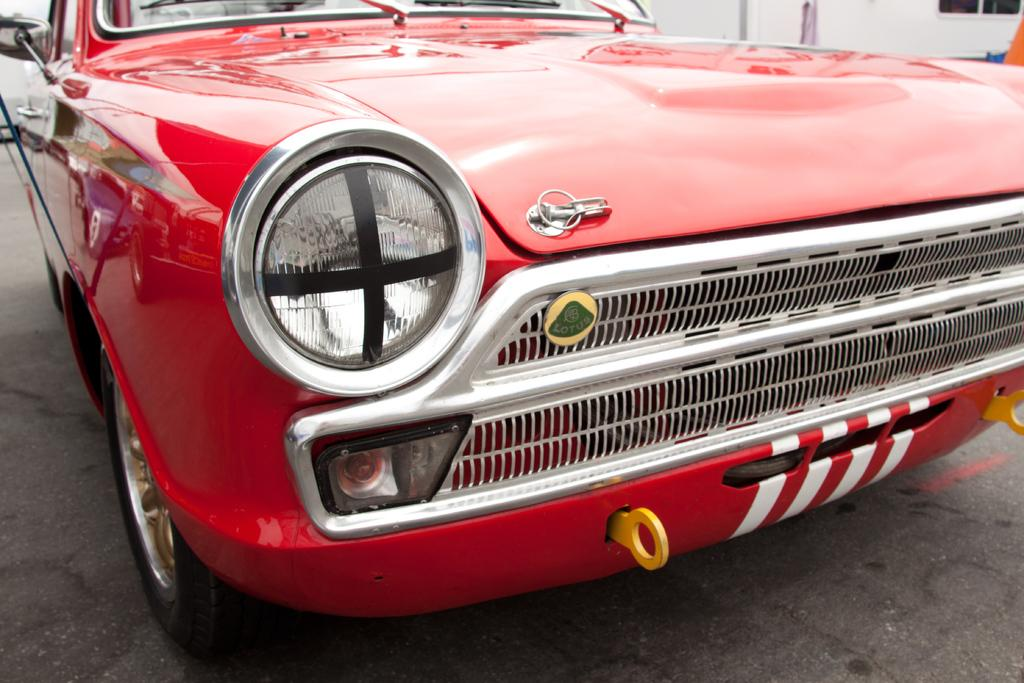What is the main subject of the image? The main subject of the image is a car. What color is the car? The car is red. Can you tell me how fast the river is flowing in the image? There is no river present in the image; it features a red car. What is the rate of the wish granted in the image? There is no mention of a wish or any related activity in the image. 